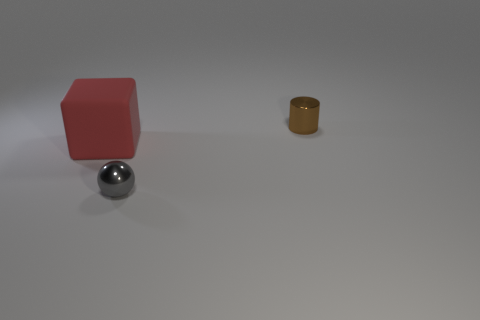Add 1 tiny brown metallic objects. How many objects exist? 4 Subtract all balls. How many objects are left? 2 Subtract 0 red cylinders. How many objects are left? 3 Subtract all yellow blocks. Subtract all green spheres. How many blocks are left? 1 Subtract all big balls. Subtract all red things. How many objects are left? 2 Add 3 large rubber things. How many large rubber things are left? 4 Add 1 brown metal cylinders. How many brown metal cylinders exist? 2 